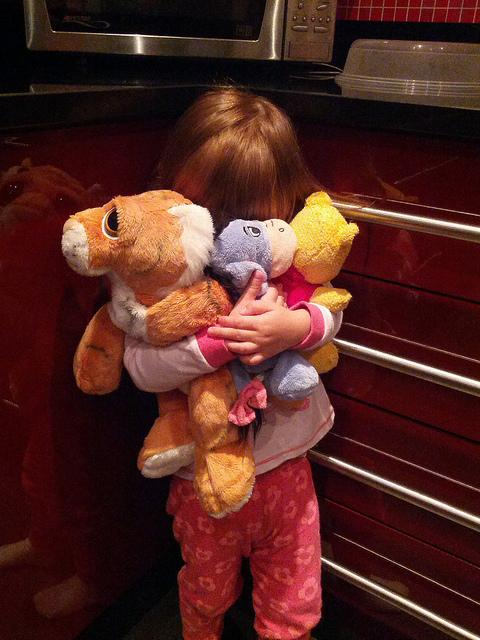What type of animal is the middle toy the child is holding?

Choices:
A) pig
B) donkey
C) tiger
D) bear donkey 